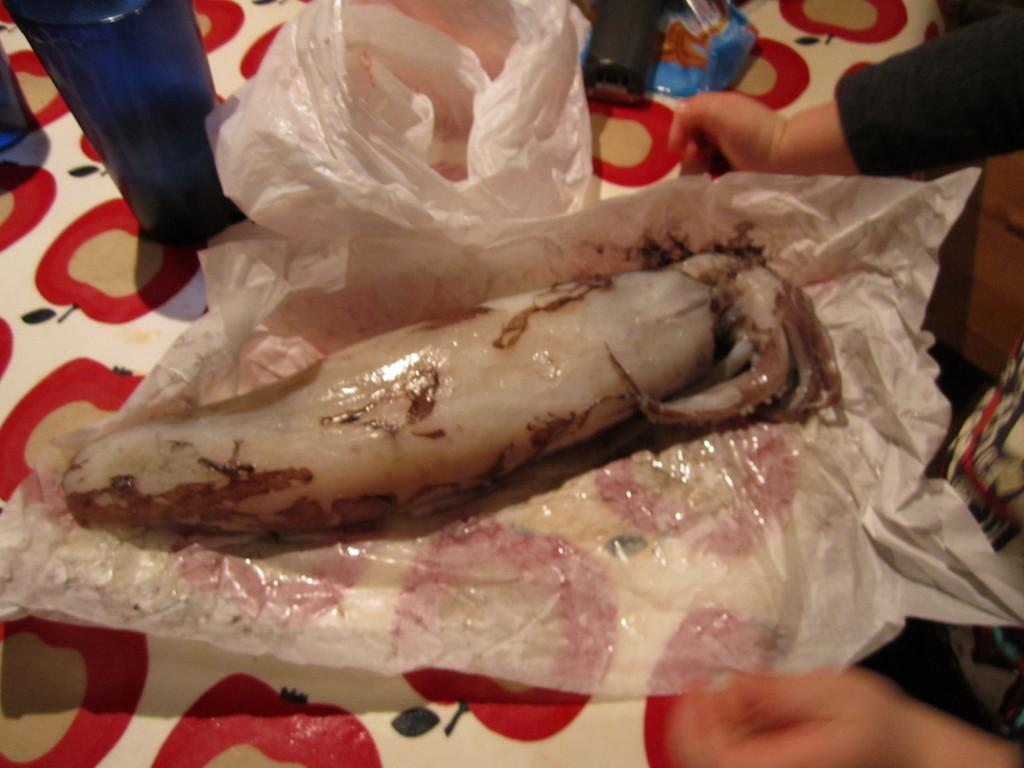What can be seen on the cover of the image? There is a food item on the cover. What is located in the background of the image? There is a bottle and a plastic surface in the background. Can you describe the person's hands visible in the background? A person's hands are visible in the background. What other objects can be seen in the background of the image? There are other objects in the background. What type of iron is being used by the girl in the image? There is no girl or iron present in the image. 